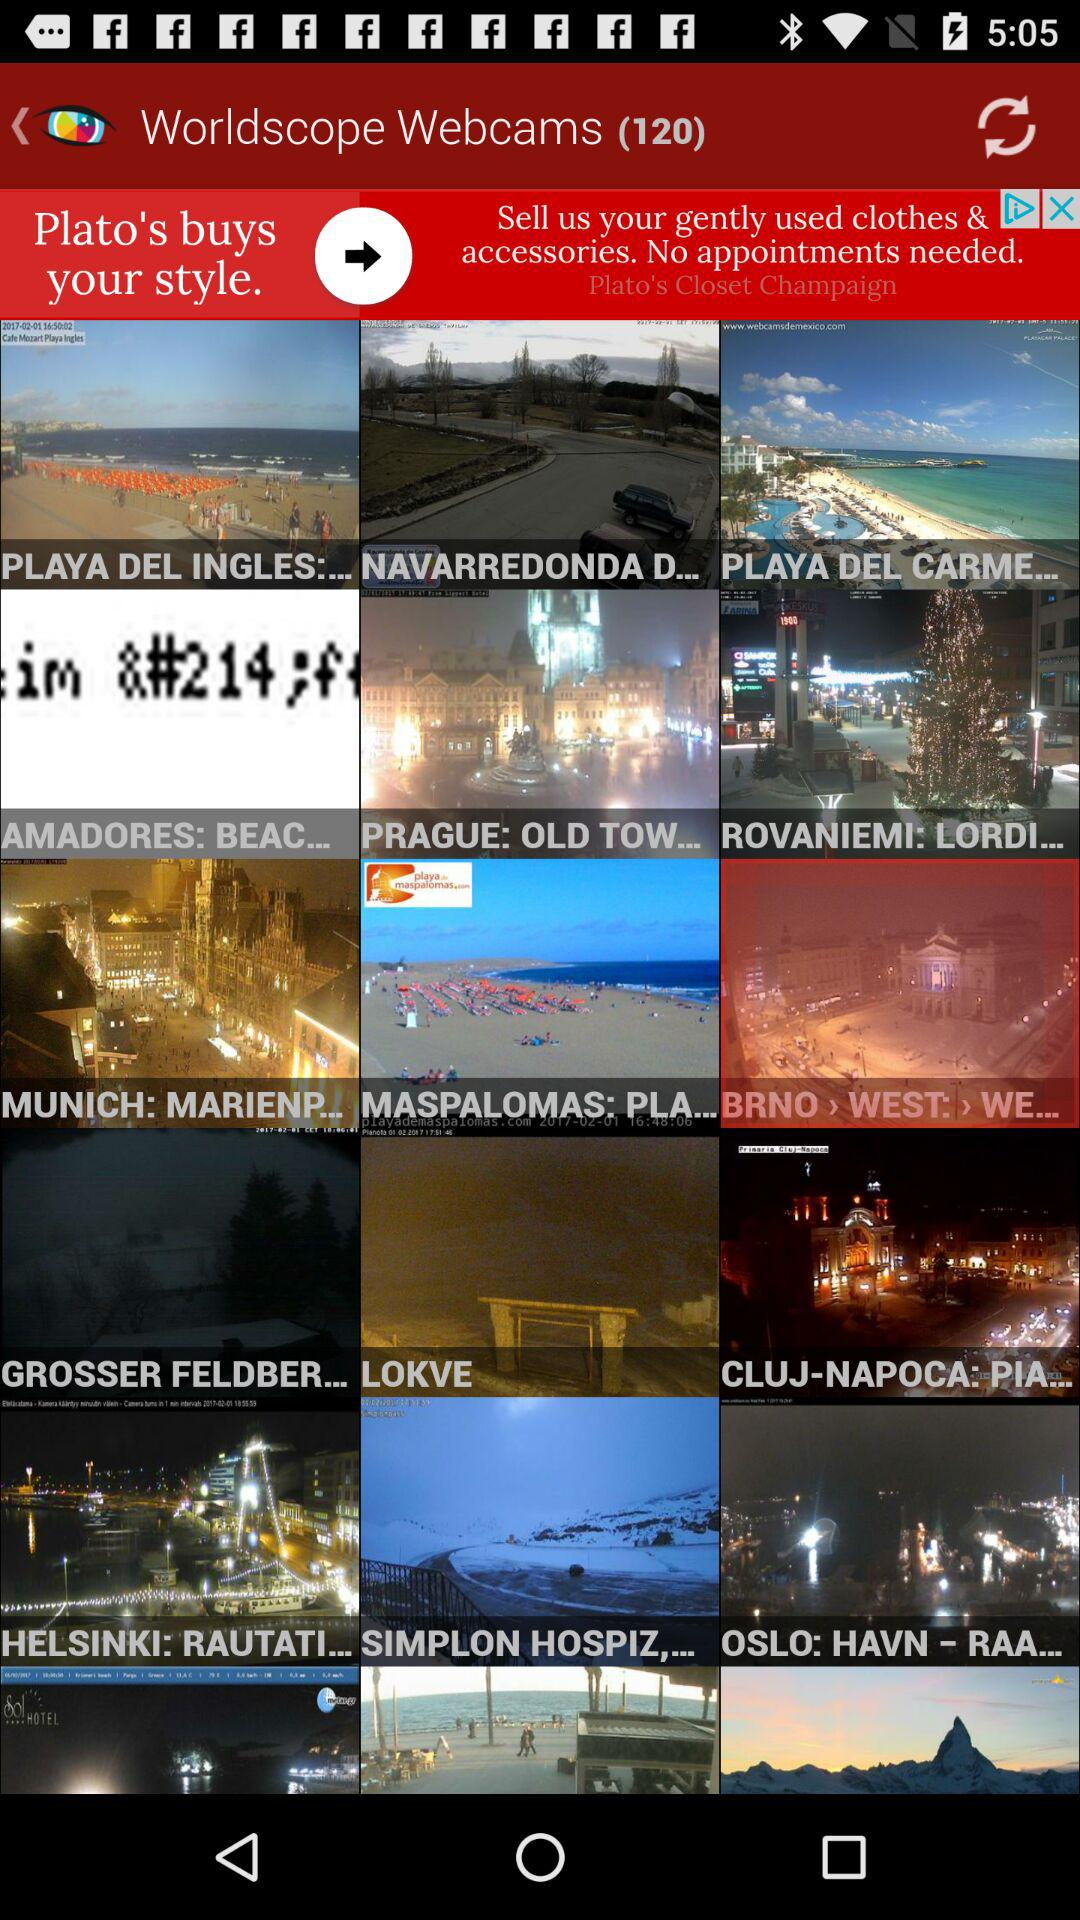How many "Worldscope Webcams" are there? There are 120 "Worldscope Webcams". 